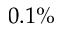Convert formula to latex. <formula><loc_0><loc_0><loc_500><loc_500>0 . 1 \%</formula> 